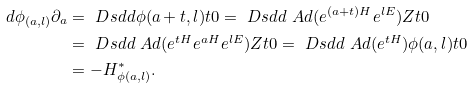<formula> <loc_0><loc_0><loc_500><loc_500>d \phi _ { ( a , l ) } \partial _ { a } & = \ D s d d { \phi ( a + t , l ) } { t } { 0 } = \ D s d d { \ A d ( e ^ { ( a + t ) H } e ^ { l E } ) Z } { t } { 0 } \\ & = \ D s d d { \ A d ( e ^ { t H } e ^ { a H } e ^ { l E } ) Z } { t } { 0 } = \ D s d d { \ A d ( e ^ { t H } ) \phi ( a , l ) } { t } { 0 } \\ & = - H ^ { * } _ { \phi ( a , l ) } .</formula> 